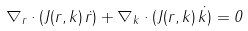Convert formula to latex. <formula><loc_0><loc_0><loc_500><loc_500>\nabla _ { r } \cdot ( J ( { r } , { k } ) \, \dot { r } ) + \nabla _ { k } \cdot ( J ( { r } , { k } ) \, \dot { k } ) = 0</formula> 